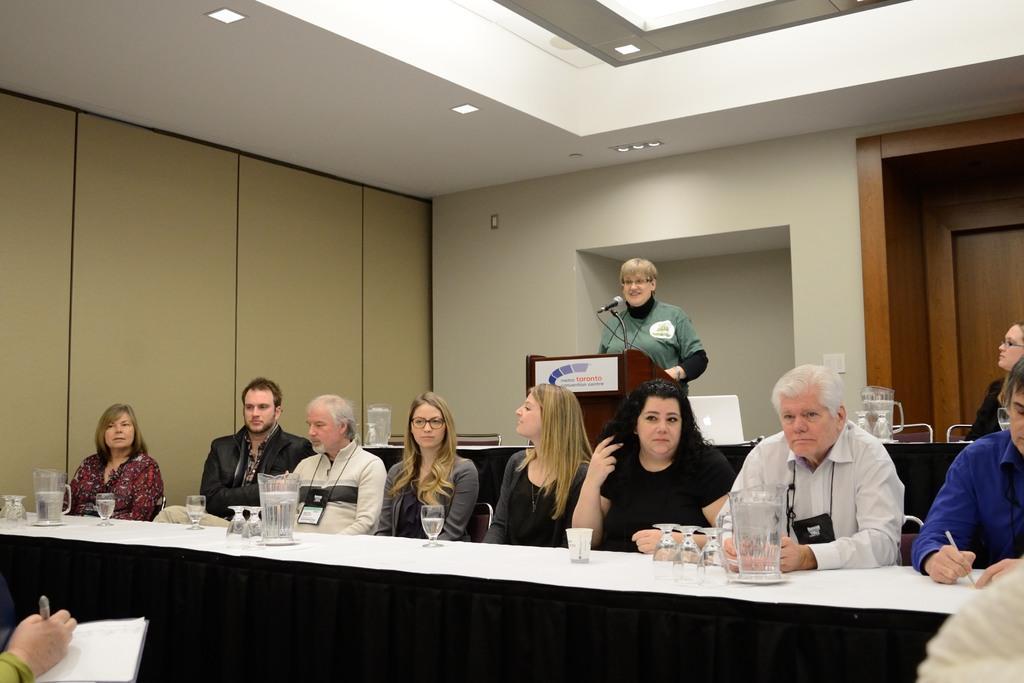How would you summarize this image in a sentence or two? In this image there is a woman is standing before a mile which is on podium. There are few persons sitting on the chair having glasses, jar and cup on it. At the left side there is a person hand holding a pen and writing on a paper. Background there is a wall. Beside there is a door. 